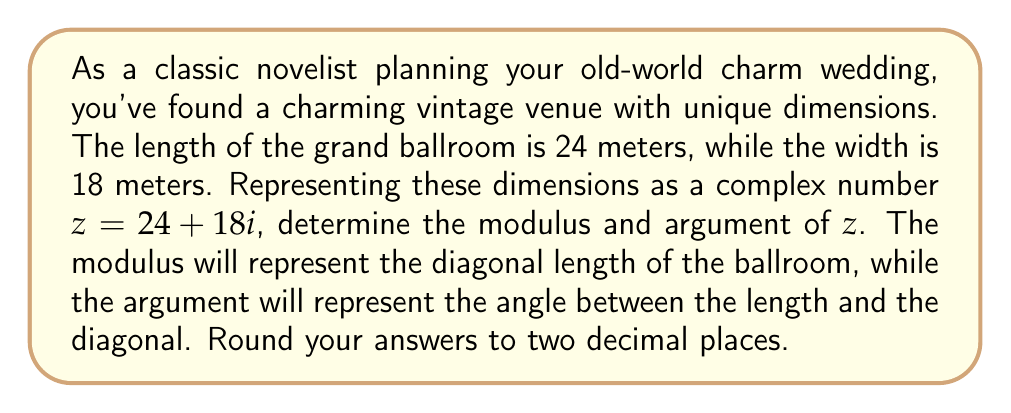What is the answer to this math problem? To solve this problem, we need to calculate the modulus and argument of the complex number $z = 24 + 18i$.

1. Modulus:
The modulus of a complex number $z = a + bi$ is given by the formula:
$$|z| = \sqrt{a^2 + b^2}$$

In this case, $a = 24$ and $b = 18$. Let's substitute these values:

$$|z| = \sqrt{24^2 + 18^2} = \sqrt{576 + 324} = \sqrt{900} = 30$$

The modulus is 30 meters, which represents the diagonal length of the ballroom.

2. Argument:
The argument of a complex number is the angle between the positive real axis and the line from the origin to the point $(a, b)$. It can be calculated using the arctangent function:

$$\arg(z) = \tan^{-1}\left(\frac{b}{a}\right)$$

However, we need to be careful about the quadrant. Since both $a$ and $b$ are positive, we're in the first quadrant, so we can use this formula directly:

$$\arg(z) = \tan^{-1}\left(\frac{18}{24}\right) = \tan^{-1}(0.75)$$

Using a calculator or computer, we get:

$$\arg(z) \approx 0.6435 \text{ radians}$$

To convert this to degrees, we multiply by $\frac{180}{\pi}$:

$$0.6435 \times \frac{180}{\pi} \approx 36.87°$$

Rounding to two decimal places, we get 36.87°.

[asy]
unitsize(4mm);
draw((0,0)--(24,0)--(24,18)--(0,0),black);
draw((0,0)--(24,18),red);
label("24m", (12,0), S);
label("18m", (24,9), E);
label("30m", (12,9), NW, red);
label("36.87°", (2,1), NE);
[/asy]
Answer: Modulus: 30.00 meters
Argument: 36.87° 